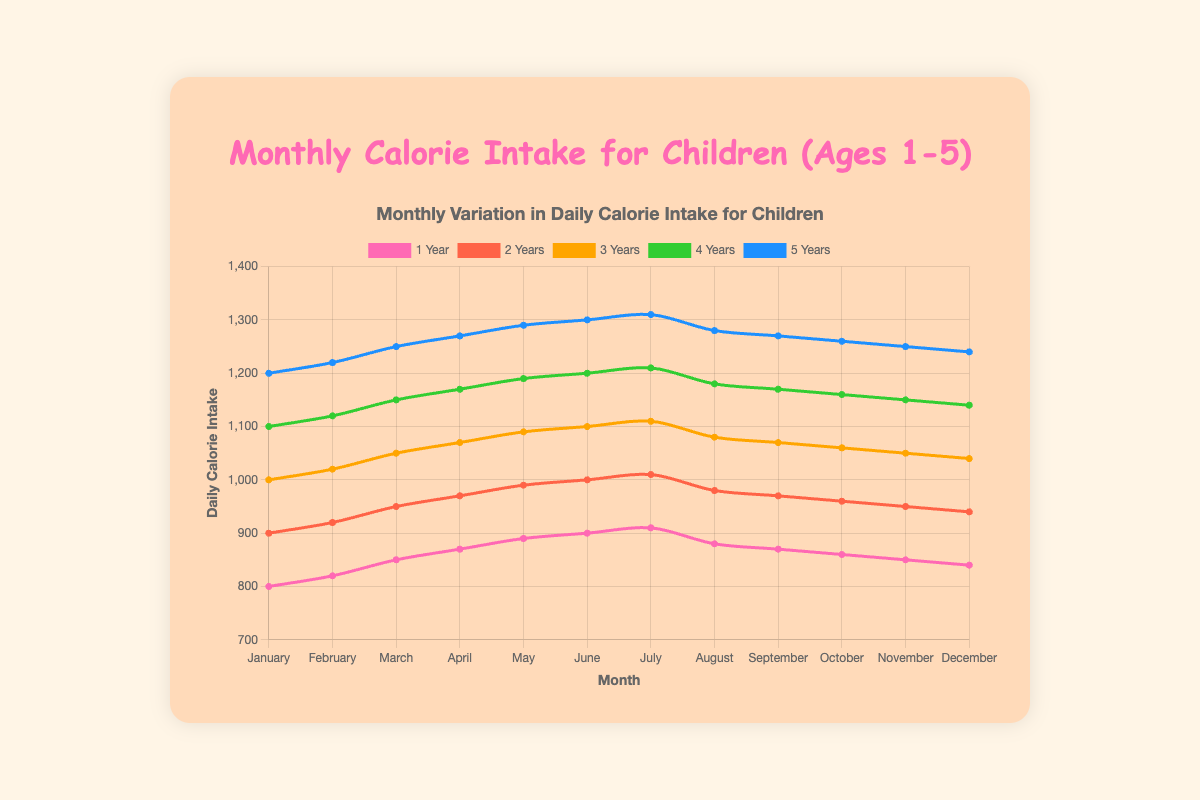Which age group had the highest daily calorie intake in July? The chart shows the highest daily calorie intake for different age groups. In July, the 5-year-olds had a daily calorie intake of 1310, which is the highest compared to other age groups.
Answer: 5-year-olds By how much did the daily calorie intake for 4-year-olds increase from January to June? In January, the daily calorie intake for 4-year-olds was 1100. In June, it was 1200. The increase can be calculated as 1200 - 1100 = 100.
Answer: 100 Which month saw the lowest daily calorie intake for 3-year-olds? To find the month with the lowest daily calorie intake for 3-year-olds, we look at the trend of their data points. December had the lowest intake at 1040 calories.
Answer: December What is the average daily calorie intake in May across all age groups? First, sum the daily calorie intake in May for all ages: 890 (1-year) + 990 (2-year) + 1090 (3-year) + 1190 (4-year) + 1290 (5-year) = 5450. Then divide by the number of age groups, 5450 / 5 = 1090.
Answer: 1090 Compare the daily calorie intake for 2-year-olds from February to March. Did it increase or decrease, and by how much? The daily calorie intake for 2-year-olds was 920 in February and increased to 950 in March. The increase is 950 - 920 = 30.
Answer: Increased by 30 What age group had the smallest fluctuation in daily calorie intake throughout the year? To determine the smallest fluctuation, we look for the age group with the most stable intake values. The intake values for 5-year-olds range from 1200 to 1310, while other groups have a wider range.
Answer: 5-year-olds During which month was the daily calorie intake for 1-year-olds the highest? The daily calorie intake for 1-year-olds is highest in July at 910 calories according to the chart.
Answer: July Calculate the total daily calorie intake for all age groups in November. Add the daily calorie intake values for all age groups in November: 850 (1-year) + 950 (2-year) + 1050 (3-year) + 1150 (4-year) + 1250 (5-year) = 5250.
Answer: 5250 